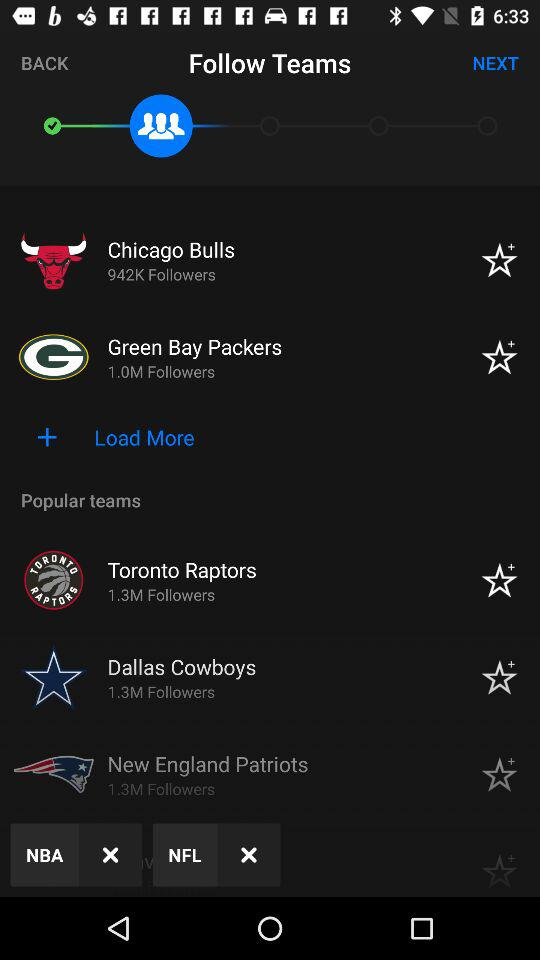What is the number of followers of the "Chicago Bulls"? The number of followers of the "Chicago Bulls" is 942K. 